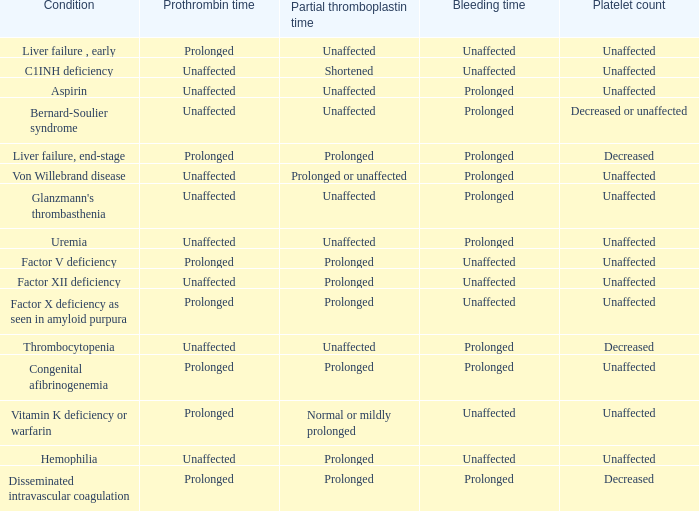Which Platelet count has a Condition of factor v deficiency? Unaffected. 